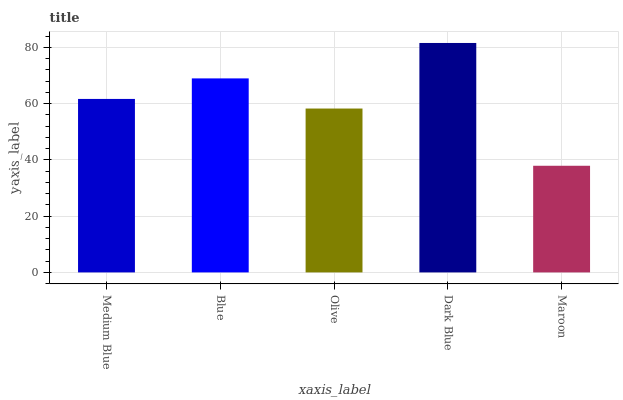Is Maroon the minimum?
Answer yes or no. Yes. Is Dark Blue the maximum?
Answer yes or no. Yes. Is Blue the minimum?
Answer yes or no. No. Is Blue the maximum?
Answer yes or no. No. Is Blue greater than Medium Blue?
Answer yes or no. Yes. Is Medium Blue less than Blue?
Answer yes or no. Yes. Is Medium Blue greater than Blue?
Answer yes or no. No. Is Blue less than Medium Blue?
Answer yes or no. No. Is Medium Blue the high median?
Answer yes or no. Yes. Is Medium Blue the low median?
Answer yes or no. Yes. Is Dark Blue the high median?
Answer yes or no. No. Is Olive the low median?
Answer yes or no. No. 